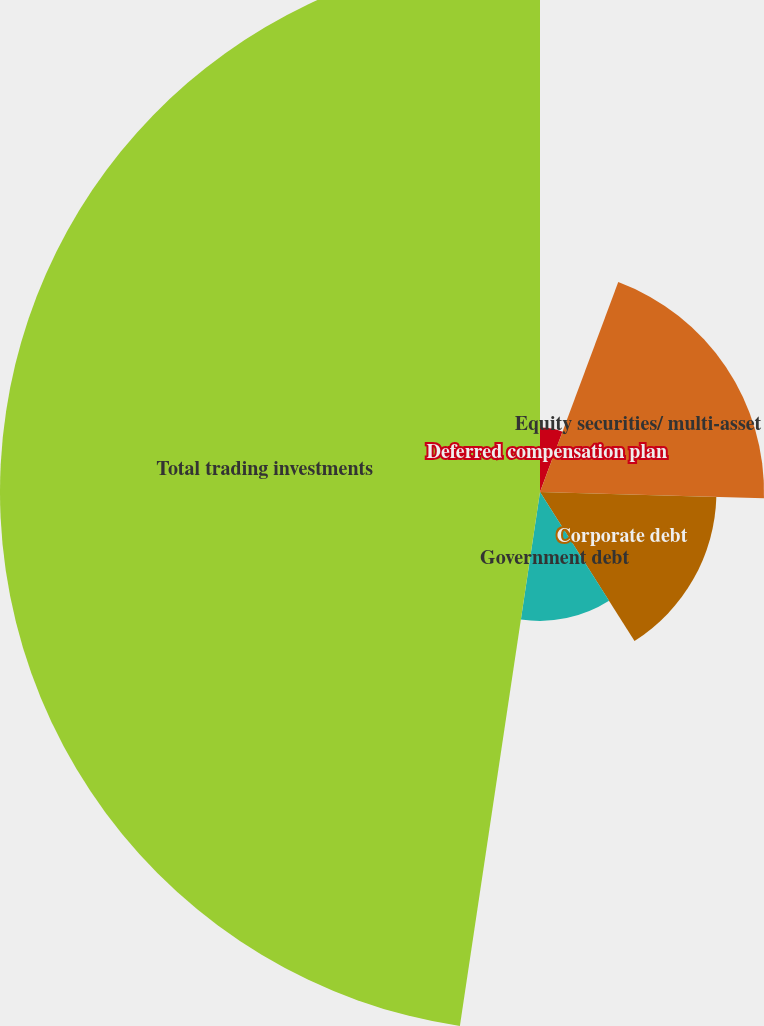Convert chart. <chart><loc_0><loc_0><loc_500><loc_500><pie_chart><fcel>Deferred compensation plan<fcel>Equity securities/ multi-asset<fcel>Corporate debt<fcel>Government debt<fcel>Total trading investments<nl><fcel>5.68%<fcel>19.76%<fcel>15.56%<fcel>11.37%<fcel>47.63%<nl></chart> 